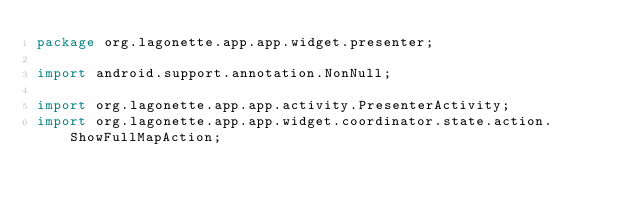<code> <loc_0><loc_0><loc_500><loc_500><_Java_>package org.lagonette.app.app.widget.presenter;

import android.support.annotation.NonNull;

import org.lagonette.app.app.activity.PresenterActivity;
import org.lagonette.app.app.widget.coordinator.state.action.ShowFullMapAction;</code> 